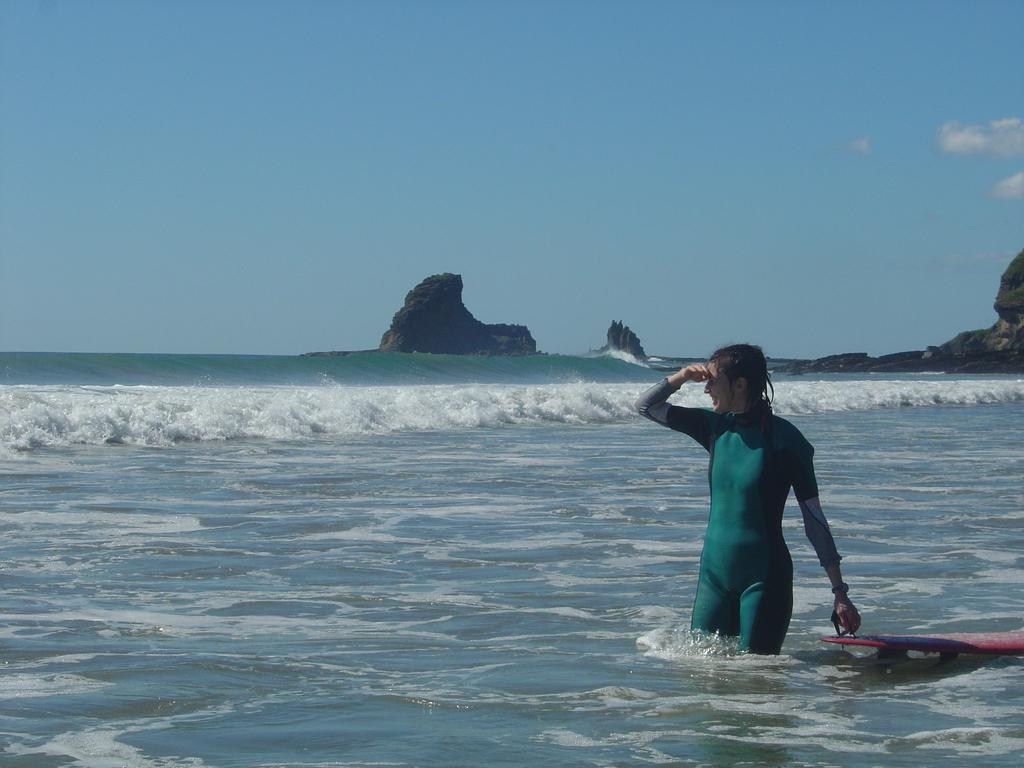What is the person on the right side of the image holding? The person is holding a surfing board. What can be seen in the background of the image? There is a sea, rocks, and the sky visible in the background of the image. What type of ink is being used by the minister in the image? There is no minister or ink present in the image. What force is being applied by the person to the surfing board in the image? The image does not show the person applying any force to the surfing board; they are simply holding it. 